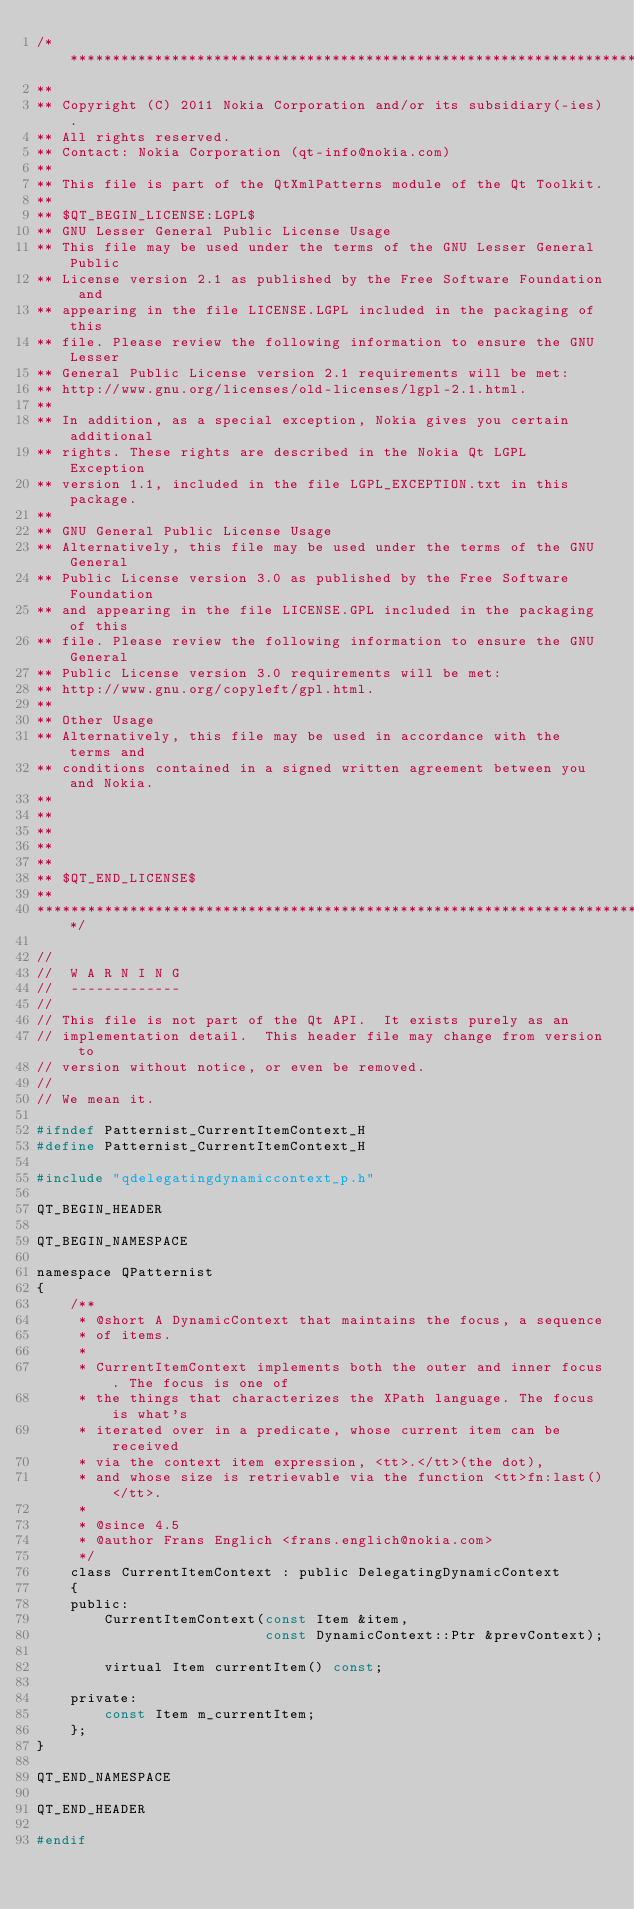<code> <loc_0><loc_0><loc_500><loc_500><_C_>/****************************************************************************
**
** Copyright (C) 2011 Nokia Corporation and/or its subsidiary(-ies).
** All rights reserved.
** Contact: Nokia Corporation (qt-info@nokia.com)
**
** This file is part of the QtXmlPatterns module of the Qt Toolkit.
**
** $QT_BEGIN_LICENSE:LGPL$
** GNU Lesser General Public License Usage
** This file may be used under the terms of the GNU Lesser General Public
** License version 2.1 as published by the Free Software Foundation and
** appearing in the file LICENSE.LGPL included in the packaging of this
** file. Please review the following information to ensure the GNU Lesser
** General Public License version 2.1 requirements will be met:
** http://www.gnu.org/licenses/old-licenses/lgpl-2.1.html.
**
** In addition, as a special exception, Nokia gives you certain additional
** rights. These rights are described in the Nokia Qt LGPL Exception
** version 1.1, included in the file LGPL_EXCEPTION.txt in this package.
**
** GNU General Public License Usage
** Alternatively, this file may be used under the terms of the GNU General
** Public License version 3.0 as published by the Free Software Foundation
** and appearing in the file LICENSE.GPL included in the packaging of this
** file. Please review the following information to ensure the GNU General
** Public License version 3.0 requirements will be met:
** http://www.gnu.org/copyleft/gpl.html.
**
** Other Usage
** Alternatively, this file may be used in accordance with the terms and
** conditions contained in a signed written agreement between you and Nokia.
**
**
**
**
**
** $QT_END_LICENSE$
**
****************************************************************************/

//
//  W A R N I N G
//  -------------
//
// This file is not part of the Qt API.  It exists purely as an
// implementation detail.  This header file may change from version to
// version without notice, or even be removed.
//
// We mean it.

#ifndef Patternist_CurrentItemContext_H
#define Patternist_CurrentItemContext_H

#include "qdelegatingdynamiccontext_p.h"

QT_BEGIN_HEADER

QT_BEGIN_NAMESPACE

namespace QPatternist
{
    /**
     * @short A DynamicContext that maintains the focus, a sequence
     * of items.
     *
     * CurrentItemContext implements both the outer and inner focus. The focus is one of
     * the things that characterizes the XPath language. The focus is what's
     * iterated over in a predicate, whose current item can be received
     * via the context item expression, <tt>.</tt>(the dot),
     * and whose size is retrievable via the function <tt>fn:last()</tt>.
     *
     * @since 4.5
     * @author Frans Englich <frans.englich@nokia.com>
     */
    class CurrentItemContext : public DelegatingDynamicContext
    {
    public:
        CurrentItemContext(const Item &item,
                           const DynamicContext::Ptr &prevContext);

        virtual Item currentItem() const;

    private:
        const Item m_currentItem;
    };
}

QT_END_NAMESPACE

QT_END_HEADER

#endif
</code> 